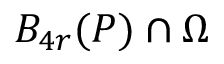Convert formula to latex. <formula><loc_0><loc_0><loc_500><loc_500>B _ { 4 r } ( P ) \cap \Omega</formula> 